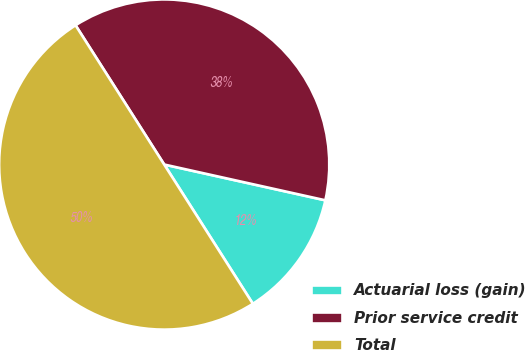Convert chart to OTSL. <chart><loc_0><loc_0><loc_500><loc_500><pie_chart><fcel>Actuarial loss (gain)<fcel>Prior service credit<fcel>Total<nl><fcel>12.5%<fcel>37.5%<fcel>50.0%<nl></chart> 